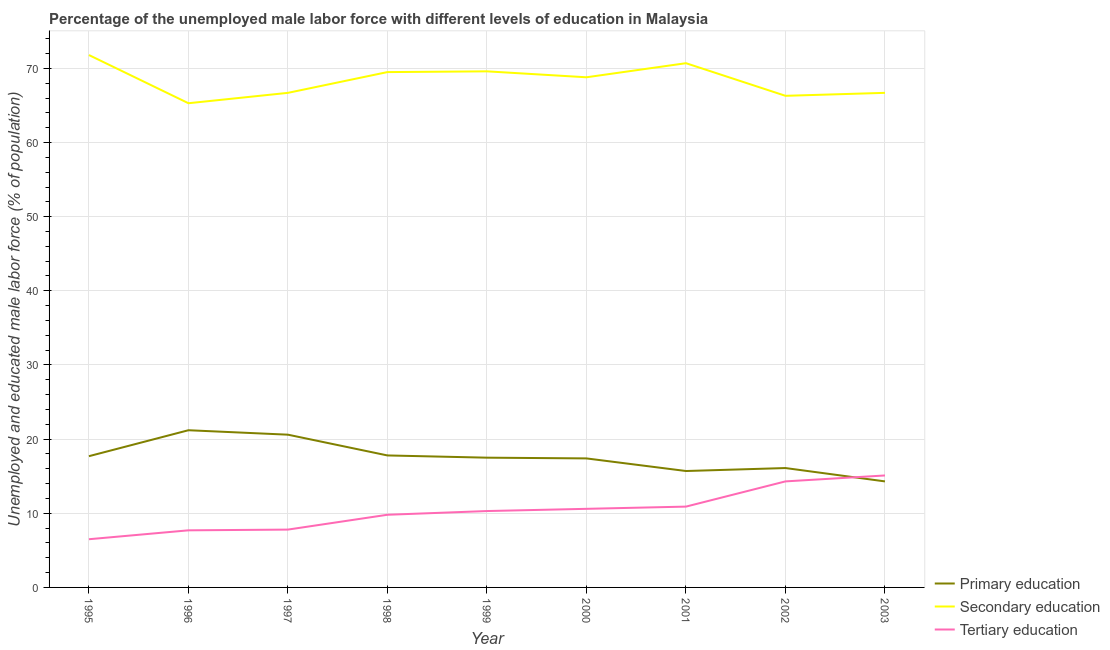What is the percentage of male labor force who received primary education in 1998?
Ensure brevity in your answer.  17.8. Across all years, what is the maximum percentage of male labor force who received tertiary education?
Ensure brevity in your answer.  15.1. Across all years, what is the minimum percentage of male labor force who received secondary education?
Offer a very short reply. 65.3. In which year was the percentage of male labor force who received primary education minimum?
Offer a terse response. 2003. What is the total percentage of male labor force who received primary education in the graph?
Keep it short and to the point. 158.3. What is the difference between the percentage of male labor force who received tertiary education in 1996 and that in 1999?
Ensure brevity in your answer.  -2.6. What is the difference between the percentage of male labor force who received tertiary education in 1995 and the percentage of male labor force who received primary education in 2003?
Your answer should be very brief. -7.8. What is the average percentage of male labor force who received primary education per year?
Keep it short and to the point. 17.59. In the year 1998, what is the difference between the percentage of male labor force who received tertiary education and percentage of male labor force who received secondary education?
Your response must be concise. -59.7. In how many years, is the percentage of male labor force who received tertiary education greater than 44 %?
Make the answer very short. 0. What is the ratio of the percentage of male labor force who received secondary education in 1996 to that in 2003?
Ensure brevity in your answer.  0.98. What is the difference between the highest and the second highest percentage of male labor force who received primary education?
Ensure brevity in your answer.  0.6. Is the sum of the percentage of male labor force who received tertiary education in 1999 and 2000 greater than the maximum percentage of male labor force who received primary education across all years?
Offer a terse response. No. Does the percentage of male labor force who received primary education monotonically increase over the years?
Ensure brevity in your answer.  No. Is the percentage of male labor force who received tertiary education strictly greater than the percentage of male labor force who received secondary education over the years?
Offer a very short reply. No. Is the percentage of male labor force who received tertiary education strictly less than the percentage of male labor force who received secondary education over the years?
Provide a short and direct response. Yes. How many years are there in the graph?
Your answer should be very brief. 9. What is the difference between two consecutive major ticks on the Y-axis?
Provide a succinct answer. 10. Does the graph contain any zero values?
Keep it short and to the point. No. How many legend labels are there?
Provide a short and direct response. 3. What is the title of the graph?
Offer a very short reply. Percentage of the unemployed male labor force with different levels of education in Malaysia. Does "Interest" appear as one of the legend labels in the graph?
Offer a very short reply. No. What is the label or title of the X-axis?
Offer a very short reply. Year. What is the label or title of the Y-axis?
Provide a succinct answer. Unemployed and educated male labor force (% of population). What is the Unemployed and educated male labor force (% of population) in Primary education in 1995?
Your answer should be very brief. 17.7. What is the Unemployed and educated male labor force (% of population) of Secondary education in 1995?
Offer a very short reply. 71.8. What is the Unemployed and educated male labor force (% of population) of Tertiary education in 1995?
Provide a short and direct response. 6.5. What is the Unemployed and educated male labor force (% of population) of Primary education in 1996?
Your response must be concise. 21.2. What is the Unemployed and educated male labor force (% of population) in Secondary education in 1996?
Ensure brevity in your answer.  65.3. What is the Unemployed and educated male labor force (% of population) of Tertiary education in 1996?
Your answer should be compact. 7.7. What is the Unemployed and educated male labor force (% of population) of Primary education in 1997?
Your answer should be compact. 20.6. What is the Unemployed and educated male labor force (% of population) of Secondary education in 1997?
Give a very brief answer. 66.7. What is the Unemployed and educated male labor force (% of population) in Tertiary education in 1997?
Make the answer very short. 7.8. What is the Unemployed and educated male labor force (% of population) in Primary education in 1998?
Offer a terse response. 17.8. What is the Unemployed and educated male labor force (% of population) in Secondary education in 1998?
Make the answer very short. 69.5. What is the Unemployed and educated male labor force (% of population) in Tertiary education in 1998?
Provide a succinct answer. 9.8. What is the Unemployed and educated male labor force (% of population) of Secondary education in 1999?
Provide a succinct answer. 69.6. What is the Unemployed and educated male labor force (% of population) of Tertiary education in 1999?
Provide a succinct answer. 10.3. What is the Unemployed and educated male labor force (% of population) in Primary education in 2000?
Your response must be concise. 17.4. What is the Unemployed and educated male labor force (% of population) in Secondary education in 2000?
Your answer should be very brief. 68.8. What is the Unemployed and educated male labor force (% of population) of Tertiary education in 2000?
Provide a short and direct response. 10.6. What is the Unemployed and educated male labor force (% of population) in Primary education in 2001?
Your answer should be very brief. 15.7. What is the Unemployed and educated male labor force (% of population) of Secondary education in 2001?
Ensure brevity in your answer.  70.7. What is the Unemployed and educated male labor force (% of population) of Tertiary education in 2001?
Ensure brevity in your answer.  10.9. What is the Unemployed and educated male labor force (% of population) in Primary education in 2002?
Ensure brevity in your answer.  16.1. What is the Unemployed and educated male labor force (% of population) in Secondary education in 2002?
Offer a very short reply. 66.3. What is the Unemployed and educated male labor force (% of population) in Tertiary education in 2002?
Offer a very short reply. 14.3. What is the Unemployed and educated male labor force (% of population) of Primary education in 2003?
Offer a terse response. 14.3. What is the Unemployed and educated male labor force (% of population) in Secondary education in 2003?
Ensure brevity in your answer.  66.7. What is the Unemployed and educated male labor force (% of population) in Tertiary education in 2003?
Ensure brevity in your answer.  15.1. Across all years, what is the maximum Unemployed and educated male labor force (% of population) in Primary education?
Offer a terse response. 21.2. Across all years, what is the maximum Unemployed and educated male labor force (% of population) in Secondary education?
Provide a succinct answer. 71.8. Across all years, what is the maximum Unemployed and educated male labor force (% of population) in Tertiary education?
Your response must be concise. 15.1. Across all years, what is the minimum Unemployed and educated male labor force (% of population) in Primary education?
Provide a short and direct response. 14.3. Across all years, what is the minimum Unemployed and educated male labor force (% of population) of Secondary education?
Your response must be concise. 65.3. What is the total Unemployed and educated male labor force (% of population) in Primary education in the graph?
Provide a succinct answer. 158.3. What is the total Unemployed and educated male labor force (% of population) in Secondary education in the graph?
Ensure brevity in your answer.  615.4. What is the total Unemployed and educated male labor force (% of population) of Tertiary education in the graph?
Your answer should be very brief. 93. What is the difference between the Unemployed and educated male labor force (% of population) of Primary education in 1995 and that in 1996?
Your answer should be very brief. -3.5. What is the difference between the Unemployed and educated male labor force (% of population) of Secondary education in 1995 and that in 1996?
Provide a succinct answer. 6.5. What is the difference between the Unemployed and educated male labor force (% of population) of Tertiary education in 1995 and that in 1996?
Make the answer very short. -1.2. What is the difference between the Unemployed and educated male labor force (% of population) of Secondary education in 1995 and that in 1997?
Ensure brevity in your answer.  5.1. What is the difference between the Unemployed and educated male labor force (% of population) in Primary education in 1995 and that in 1998?
Offer a terse response. -0.1. What is the difference between the Unemployed and educated male labor force (% of population) in Primary education in 1995 and that in 2000?
Offer a terse response. 0.3. What is the difference between the Unemployed and educated male labor force (% of population) in Tertiary education in 1995 and that in 2000?
Your answer should be very brief. -4.1. What is the difference between the Unemployed and educated male labor force (% of population) of Primary education in 1995 and that in 2001?
Ensure brevity in your answer.  2. What is the difference between the Unemployed and educated male labor force (% of population) of Secondary education in 1995 and that in 2001?
Make the answer very short. 1.1. What is the difference between the Unemployed and educated male labor force (% of population) of Primary education in 1995 and that in 2002?
Offer a very short reply. 1.6. What is the difference between the Unemployed and educated male labor force (% of population) of Tertiary education in 1995 and that in 2003?
Your answer should be very brief. -8.6. What is the difference between the Unemployed and educated male labor force (% of population) in Primary education in 1996 and that in 1998?
Keep it short and to the point. 3.4. What is the difference between the Unemployed and educated male labor force (% of population) of Secondary education in 1996 and that in 1998?
Ensure brevity in your answer.  -4.2. What is the difference between the Unemployed and educated male labor force (% of population) of Primary education in 1996 and that in 1999?
Offer a terse response. 3.7. What is the difference between the Unemployed and educated male labor force (% of population) in Primary education in 1996 and that in 2000?
Ensure brevity in your answer.  3.8. What is the difference between the Unemployed and educated male labor force (% of population) in Primary education in 1996 and that in 2002?
Offer a terse response. 5.1. What is the difference between the Unemployed and educated male labor force (% of population) of Primary education in 1996 and that in 2003?
Make the answer very short. 6.9. What is the difference between the Unemployed and educated male labor force (% of population) of Secondary education in 1996 and that in 2003?
Make the answer very short. -1.4. What is the difference between the Unemployed and educated male labor force (% of population) of Tertiary education in 1996 and that in 2003?
Give a very brief answer. -7.4. What is the difference between the Unemployed and educated male labor force (% of population) in Primary education in 1997 and that in 1998?
Keep it short and to the point. 2.8. What is the difference between the Unemployed and educated male labor force (% of population) of Primary education in 1997 and that in 1999?
Offer a terse response. 3.1. What is the difference between the Unemployed and educated male labor force (% of population) of Tertiary education in 1997 and that in 1999?
Give a very brief answer. -2.5. What is the difference between the Unemployed and educated male labor force (% of population) of Primary education in 1997 and that in 2000?
Make the answer very short. 3.2. What is the difference between the Unemployed and educated male labor force (% of population) of Secondary education in 1997 and that in 2000?
Make the answer very short. -2.1. What is the difference between the Unemployed and educated male labor force (% of population) of Secondary education in 1997 and that in 2001?
Make the answer very short. -4. What is the difference between the Unemployed and educated male labor force (% of population) in Primary education in 1997 and that in 2002?
Offer a terse response. 4.5. What is the difference between the Unemployed and educated male labor force (% of population) in Secondary education in 1997 and that in 2002?
Your answer should be very brief. 0.4. What is the difference between the Unemployed and educated male labor force (% of population) of Primary education in 1997 and that in 2003?
Offer a very short reply. 6.3. What is the difference between the Unemployed and educated male labor force (% of population) in Primary education in 1998 and that in 2000?
Provide a succinct answer. 0.4. What is the difference between the Unemployed and educated male labor force (% of population) of Secondary education in 1998 and that in 2000?
Give a very brief answer. 0.7. What is the difference between the Unemployed and educated male labor force (% of population) of Primary education in 1998 and that in 2001?
Offer a very short reply. 2.1. What is the difference between the Unemployed and educated male labor force (% of population) of Secondary education in 1998 and that in 2001?
Make the answer very short. -1.2. What is the difference between the Unemployed and educated male labor force (% of population) in Primary education in 1998 and that in 2003?
Provide a succinct answer. 3.5. What is the difference between the Unemployed and educated male labor force (% of population) of Primary education in 1999 and that in 2000?
Your answer should be very brief. 0.1. What is the difference between the Unemployed and educated male labor force (% of population) of Primary education in 1999 and that in 2001?
Provide a succinct answer. 1.8. What is the difference between the Unemployed and educated male labor force (% of population) in Secondary education in 1999 and that in 2002?
Provide a succinct answer. 3.3. What is the difference between the Unemployed and educated male labor force (% of population) in Secondary education in 1999 and that in 2003?
Give a very brief answer. 2.9. What is the difference between the Unemployed and educated male labor force (% of population) of Primary education in 2000 and that in 2001?
Give a very brief answer. 1.7. What is the difference between the Unemployed and educated male labor force (% of population) of Secondary education in 2000 and that in 2002?
Give a very brief answer. 2.5. What is the difference between the Unemployed and educated male labor force (% of population) of Tertiary education in 2000 and that in 2002?
Your answer should be very brief. -3.7. What is the difference between the Unemployed and educated male labor force (% of population) of Primary education in 2000 and that in 2003?
Your answer should be compact. 3.1. What is the difference between the Unemployed and educated male labor force (% of population) of Secondary education in 2000 and that in 2003?
Your answer should be very brief. 2.1. What is the difference between the Unemployed and educated male labor force (% of population) in Tertiary education in 2000 and that in 2003?
Make the answer very short. -4.5. What is the difference between the Unemployed and educated male labor force (% of population) in Primary education in 2001 and that in 2002?
Your answer should be compact. -0.4. What is the difference between the Unemployed and educated male labor force (% of population) in Primary education in 2001 and that in 2003?
Ensure brevity in your answer.  1.4. What is the difference between the Unemployed and educated male labor force (% of population) of Secondary education in 2001 and that in 2003?
Provide a short and direct response. 4. What is the difference between the Unemployed and educated male labor force (% of population) of Tertiary education in 2001 and that in 2003?
Provide a succinct answer. -4.2. What is the difference between the Unemployed and educated male labor force (% of population) of Primary education in 2002 and that in 2003?
Offer a terse response. 1.8. What is the difference between the Unemployed and educated male labor force (% of population) in Secondary education in 2002 and that in 2003?
Provide a succinct answer. -0.4. What is the difference between the Unemployed and educated male labor force (% of population) of Primary education in 1995 and the Unemployed and educated male labor force (% of population) of Secondary education in 1996?
Your answer should be very brief. -47.6. What is the difference between the Unemployed and educated male labor force (% of population) in Secondary education in 1995 and the Unemployed and educated male labor force (% of population) in Tertiary education in 1996?
Ensure brevity in your answer.  64.1. What is the difference between the Unemployed and educated male labor force (% of population) of Primary education in 1995 and the Unemployed and educated male labor force (% of population) of Secondary education in 1997?
Offer a terse response. -49. What is the difference between the Unemployed and educated male labor force (% of population) in Primary education in 1995 and the Unemployed and educated male labor force (% of population) in Tertiary education in 1997?
Provide a succinct answer. 9.9. What is the difference between the Unemployed and educated male labor force (% of population) of Primary education in 1995 and the Unemployed and educated male labor force (% of population) of Secondary education in 1998?
Offer a very short reply. -51.8. What is the difference between the Unemployed and educated male labor force (% of population) in Primary education in 1995 and the Unemployed and educated male labor force (% of population) in Secondary education in 1999?
Make the answer very short. -51.9. What is the difference between the Unemployed and educated male labor force (% of population) of Primary education in 1995 and the Unemployed and educated male labor force (% of population) of Tertiary education in 1999?
Offer a very short reply. 7.4. What is the difference between the Unemployed and educated male labor force (% of population) in Secondary education in 1995 and the Unemployed and educated male labor force (% of population) in Tertiary education in 1999?
Your answer should be very brief. 61.5. What is the difference between the Unemployed and educated male labor force (% of population) in Primary education in 1995 and the Unemployed and educated male labor force (% of population) in Secondary education in 2000?
Make the answer very short. -51.1. What is the difference between the Unemployed and educated male labor force (% of population) of Primary education in 1995 and the Unemployed and educated male labor force (% of population) of Tertiary education in 2000?
Give a very brief answer. 7.1. What is the difference between the Unemployed and educated male labor force (% of population) in Secondary education in 1995 and the Unemployed and educated male labor force (% of population) in Tertiary education in 2000?
Your response must be concise. 61.2. What is the difference between the Unemployed and educated male labor force (% of population) of Primary education in 1995 and the Unemployed and educated male labor force (% of population) of Secondary education in 2001?
Your answer should be compact. -53. What is the difference between the Unemployed and educated male labor force (% of population) of Primary education in 1995 and the Unemployed and educated male labor force (% of population) of Tertiary education in 2001?
Offer a terse response. 6.8. What is the difference between the Unemployed and educated male labor force (% of population) in Secondary education in 1995 and the Unemployed and educated male labor force (% of population) in Tertiary education in 2001?
Your answer should be compact. 60.9. What is the difference between the Unemployed and educated male labor force (% of population) in Primary education in 1995 and the Unemployed and educated male labor force (% of population) in Secondary education in 2002?
Offer a very short reply. -48.6. What is the difference between the Unemployed and educated male labor force (% of population) in Secondary education in 1995 and the Unemployed and educated male labor force (% of population) in Tertiary education in 2002?
Make the answer very short. 57.5. What is the difference between the Unemployed and educated male labor force (% of population) in Primary education in 1995 and the Unemployed and educated male labor force (% of population) in Secondary education in 2003?
Keep it short and to the point. -49. What is the difference between the Unemployed and educated male labor force (% of population) in Secondary education in 1995 and the Unemployed and educated male labor force (% of population) in Tertiary education in 2003?
Provide a short and direct response. 56.7. What is the difference between the Unemployed and educated male labor force (% of population) of Primary education in 1996 and the Unemployed and educated male labor force (% of population) of Secondary education in 1997?
Your answer should be compact. -45.5. What is the difference between the Unemployed and educated male labor force (% of population) of Secondary education in 1996 and the Unemployed and educated male labor force (% of population) of Tertiary education in 1997?
Your answer should be compact. 57.5. What is the difference between the Unemployed and educated male labor force (% of population) of Primary education in 1996 and the Unemployed and educated male labor force (% of population) of Secondary education in 1998?
Provide a short and direct response. -48.3. What is the difference between the Unemployed and educated male labor force (% of population) in Secondary education in 1996 and the Unemployed and educated male labor force (% of population) in Tertiary education in 1998?
Keep it short and to the point. 55.5. What is the difference between the Unemployed and educated male labor force (% of population) of Primary education in 1996 and the Unemployed and educated male labor force (% of population) of Secondary education in 1999?
Provide a succinct answer. -48.4. What is the difference between the Unemployed and educated male labor force (% of population) of Secondary education in 1996 and the Unemployed and educated male labor force (% of population) of Tertiary education in 1999?
Offer a terse response. 55. What is the difference between the Unemployed and educated male labor force (% of population) of Primary education in 1996 and the Unemployed and educated male labor force (% of population) of Secondary education in 2000?
Provide a succinct answer. -47.6. What is the difference between the Unemployed and educated male labor force (% of population) in Primary education in 1996 and the Unemployed and educated male labor force (% of population) in Tertiary education in 2000?
Give a very brief answer. 10.6. What is the difference between the Unemployed and educated male labor force (% of population) of Secondary education in 1996 and the Unemployed and educated male labor force (% of population) of Tertiary education in 2000?
Offer a very short reply. 54.7. What is the difference between the Unemployed and educated male labor force (% of population) in Primary education in 1996 and the Unemployed and educated male labor force (% of population) in Secondary education in 2001?
Give a very brief answer. -49.5. What is the difference between the Unemployed and educated male labor force (% of population) in Secondary education in 1996 and the Unemployed and educated male labor force (% of population) in Tertiary education in 2001?
Your answer should be compact. 54.4. What is the difference between the Unemployed and educated male labor force (% of population) of Primary education in 1996 and the Unemployed and educated male labor force (% of population) of Secondary education in 2002?
Offer a very short reply. -45.1. What is the difference between the Unemployed and educated male labor force (% of population) of Primary education in 1996 and the Unemployed and educated male labor force (% of population) of Tertiary education in 2002?
Provide a succinct answer. 6.9. What is the difference between the Unemployed and educated male labor force (% of population) of Primary education in 1996 and the Unemployed and educated male labor force (% of population) of Secondary education in 2003?
Provide a short and direct response. -45.5. What is the difference between the Unemployed and educated male labor force (% of population) in Secondary education in 1996 and the Unemployed and educated male labor force (% of population) in Tertiary education in 2003?
Offer a terse response. 50.2. What is the difference between the Unemployed and educated male labor force (% of population) in Primary education in 1997 and the Unemployed and educated male labor force (% of population) in Secondary education in 1998?
Ensure brevity in your answer.  -48.9. What is the difference between the Unemployed and educated male labor force (% of population) in Secondary education in 1997 and the Unemployed and educated male labor force (% of population) in Tertiary education in 1998?
Keep it short and to the point. 56.9. What is the difference between the Unemployed and educated male labor force (% of population) in Primary education in 1997 and the Unemployed and educated male labor force (% of population) in Secondary education in 1999?
Ensure brevity in your answer.  -49. What is the difference between the Unemployed and educated male labor force (% of population) of Secondary education in 1997 and the Unemployed and educated male labor force (% of population) of Tertiary education in 1999?
Provide a succinct answer. 56.4. What is the difference between the Unemployed and educated male labor force (% of population) of Primary education in 1997 and the Unemployed and educated male labor force (% of population) of Secondary education in 2000?
Offer a very short reply. -48.2. What is the difference between the Unemployed and educated male labor force (% of population) in Primary education in 1997 and the Unemployed and educated male labor force (% of population) in Tertiary education in 2000?
Keep it short and to the point. 10. What is the difference between the Unemployed and educated male labor force (% of population) of Secondary education in 1997 and the Unemployed and educated male labor force (% of population) of Tertiary education in 2000?
Give a very brief answer. 56.1. What is the difference between the Unemployed and educated male labor force (% of population) of Primary education in 1997 and the Unemployed and educated male labor force (% of population) of Secondary education in 2001?
Your response must be concise. -50.1. What is the difference between the Unemployed and educated male labor force (% of population) in Secondary education in 1997 and the Unemployed and educated male labor force (% of population) in Tertiary education in 2001?
Provide a succinct answer. 55.8. What is the difference between the Unemployed and educated male labor force (% of population) of Primary education in 1997 and the Unemployed and educated male labor force (% of population) of Secondary education in 2002?
Give a very brief answer. -45.7. What is the difference between the Unemployed and educated male labor force (% of population) of Primary education in 1997 and the Unemployed and educated male labor force (% of population) of Tertiary education in 2002?
Offer a terse response. 6.3. What is the difference between the Unemployed and educated male labor force (% of population) in Secondary education in 1997 and the Unemployed and educated male labor force (% of population) in Tertiary education in 2002?
Offer a very short reply. 52.4. What is the difference between the Unemployed and educated male labor force (% of population) in Primary education in 1997 and the Unemployed and educated male labor force (% of population) in Secondary education in 2003?
Provide a short and direct response. -46.1. What is the difference between the Unemployed and educated male labor force (% of population) in Primary education in 1997 and the Unemployed and educated male labor force (% of population) in Tertiary education in 2003?
Ensure brevity in your answer.  5.5. What is the difference between the Unemployed and educated male labor force (% of population) of Secondary education in 1997 and the Unemployed and educated male labor force (% of population) of Tertiary education in 2003?
Your answer should be compact. 51.6. What is the difference between the Unemployed and educated male labor force (% of population) of Primary education in 1998 and the Unemployed and educated male labor force (% of population) of Secondary education in 1999?
Ensure brevity in your answer.  -51.8. What is the difference between the Unemployed and educated male labor force (% of population) of Primary education in 1998 and the Unemployed and educated male labor force (% of population) of Tertiary education in 1999?
Ensure brevity in your answer.  7.5. What is the difference between the Unemployed and educated male labor force (% of population) of Secondary education in 1998 and the Unemployed and educated male labor force (% of population) of Tertiary education in 1999?
Your answer should be compact. 59.2. What is the difference between the Unemployed and educated male labor force (% of population) of Primary education in 1998 and the Unemployed and educated male labor force (% of population) of Secondary education in 2000?
Provide a succinct answer. -51. What is the difference between the Unemployed and educated male labor force (% of population) of Primary education in 1998 and the Unemployed and educated male labor force (% of population) of Tertiary education in 2000?
Provide a succinct answer. 7.2. What is the difference between the Unemployed and educated male labor force (% of population) of Secondary education in 1998 and the Unemployed and educated male labor force (% of population) of Tertiary education in 2000?
Your response must be concise. 58.9. What is the difference between the Unemployed and educated male labor force (% of population) of Primary education in 1998 and the Unemployed and educated male labor force (% of population) of Secondary education in 2001?
Make the answer very short. -52.9. What is the difference between the Unemployed and educated male labor force (% of population) of Secondary education in 1998 and the Unemployed and educated male labor force (% of population) of Tertiary education in 2001?
Keep it short and to the point. 58.6. What is the difference between the Unemployed and educated male labor force (% of population) in Primary education in 1998 and the Unemployed and educated male labor force (% of population) in Secondary education in 2002?
Offer a very short reply. -48.5. What is the difference between the Unemployed and educated male labor force (% of population) of Primary education in 1998 and the Unemployed and educated male labor force (% of population) of Tertiary education in 2002?
Your answer should be very brief. 3.5. What is the difference between the Unemployed and educated male labor force (% of population) in Secondary education in 1998 and the Unemployed and educated male labor force (% of population) in Tertiary education in 2002?
Keep it short and to the point. 55.2. What is the difference between the Unemployed and educated male labor force (% of population) in Primary education in 1998 and the Unemployed and educated male labor force (% of population) in Secondary education in 2003?
Make the answer very short. -48.9. What is the difference between the Unemployed and educated male labor force (% of population) of Primary education in 1998 and the Unemployed and educated male labor force (% of population) of Tertiary education in 2003?
Make the answer very short. 2.7. What is the difference between the Unemployed and educated male labor force (% of population) of Secondary education in 1998 and the Unemployed and educated male labor force (% of population) of Tertiary education in 2003?
Give a very brief answer. 54.4. What is the difference between the Unemployed and educated male labor force (% of population) of Primary education in 1999 and the Unemployed and educated male labor force (% of population) of Secondary education in 2000?
Your answer should be compact. -51.3. What is the difference between the Unemployed and educated male labor force (% of population) of Primary education in 1999 and the Unemployed and educated male labor force (% of population) of Secondary education in 2001?
Provide a succinct answer. -53.2. What is the difference between the Unemployed and educated male labor force (% of population) in Secondary education in 1999 and the Unemployed and educated male labor force (% of population) in Tertiary education in 2001?
Your answer should be very brief. 58.7. What is the difference between the Unemployed and educated male labor force (% of population) of Primary education in 1999 and the Unemployed and educated male labor force (% of population) of Secondary education in 2002?
Make the answer very short. -48.8. What is the difference between the Unemployed and educated male labor force (% of population) of Secondary education in 1999 and the Unemployed and educated male labor force (% of population) of Tertiary education in 2002?
Provide a succinct answer. 55.3. What is the difference between the Unemployed and educated male labor force (% of population) of Primary education in 1999 and the Unemployed and educated male labor force (% of population) of Secondary education in 2003?
Your answer should be very brief. -49.2. What is the difference between the Unemployed and educated male labor force (% of population) of Primary education in 1999 and the Unemployed and educated male labor force (% of population) of Tertiary education in 2003?
Offer a terse response. 2.4. What is the difference between the Unemployed and educated male labor force (% of population) in Secondary education in 1999 and the Unemployed and educated male labor force (% of population) in Tertiary education in 2003?
Offer a very short reply. 54.5. What is the difference between the Unemployed and educated male labor force (% of population) of Primary education in 2000 and the Unemployed and educated male labor force (% of population) of Secondary education in 2001?
Ensure brevity in your answer.  -53.3. What is the difference between the Unemployed and educated male labor force (% of population) in Primary education in 2000 and the Unemployed and educated male labor force (% of population) in Tertiary education in 2001?
Your response must be concise. 6.5. What is the difference between the Unemployed and educated male labor force (% of population) in Secondary education in 2000 and the Unemployed and educated male labor force (% of population) in Tertiary education in 2001?
Provide a short and direct response. 57.9. What is the difference between the Unemployed and educated male labor force (% of population) of Primary education in 2000 and the Unemployed and educated male labor force (% of population) of Secondary education in 2002?
Keep it short and to the point. -48.9. What is the difference between the Unemployed and educated male labor force (% of population) of Secondary education in 2000 and the Unemployed and educated male labor force (% of population) of Tertiary education in 2002?
Make the answer very short. 54.5. What is the difference between the Unemployed and educated male labor force (% of population) in Primary education in 2000 and the Unemployed and educated male labor force (% of population) in Secondary education in 2003?
Offer a terse response. -49.3. What is the difference between the Unemployed and educated male labor force (% of population) of Secondary education in 2000 and the Unemployed and educated male labor force (% of population) of Tertiary education in 2003?
Offer a terse response. 53.7. What is the difference between the Unemployed and educated male labor force (% of population) in Primary education in 2001 and the Unemployed and educated male labor force (% of population) in Secondary education in 2002?
Offer a terse response. -50.6. What is the difference between the Unemployed and educated male labor force (% of population) of Secondary education in 2001 and the Unemployed and educated male labor force (% of population) of Tertiary education in 2002?
Give a very brief answer. 56.4. What is the difference between the Unemployed and educated male labor force (% of population) in Primary education in 2001 and the Unemployed and educated male labor force (% of population) in Secondary education in 2003?
Your answer should be compact. -51. What is the difference between the Unemployed and educated male labor force (% of population) of Primary education in 2001 and the Unemployed and educated male labor force (% of population) of Tertiary education in 2003?
Make the answer very short. 0.6. What is the difference between the Unemployed and educated male labor force (% of population) in Secondary education in 2001 and the Unemployed and educated male labor force (% of population) in Tertiary education in 2003?
Provide a succinct answer. 55.6. What is the difference between the Unemployed and educated male labor force (% of population) in Primary education in 2002 and the Unemployed and educated male labor force (% of population) in Secondary education in 2003?
Offer a very short reply. -50.6. What is the difference between the Unemployed and educated male labor force (% of population) in Primary education in 2002 and the Unemployed and educated male labor force (% of population) in Tertiary education in 2003?
Ensure brevity in your answer.  1. What is the difference between the Unemployed and educated male labor force (% of population) in Secondary education in 2002 and the Unemployed and educated male labor force (% of population) in Tertiary education in 2003?
Provide a succinct answer. 51.2. What is the average Unemployed and educated male labor force (% of population) of Primary education per year?
Keep it short and to the point. 17.59. What is the average Unemployed and educated male labor force (% of population) in Secondary education per year?
Your answer should be compact. 68.38. What is the average Unemployed and educated male labor force (% of population) of Tertiary education per year?
Your answer should be very brief. 10.33. In the year 1995, what is the difference between the Unemployed and educated male labor force (% of population) of Primary education and Unemployed and educated male labor force (% of population) of Secondary education?
Make the answer very short. -54.1. In the year 1995, what is the difference between the Unemployed and educated male labor force (% of population) in Secondary education and Unemployed and educated male labor force (% of population) in Tertiary education?
Provide a short and direct response. 65.3. In the year 1996, what is the difference between the Unemployed and educated male labor force (% of population) in Primary education and Unemployed and educated male labor force (% of population) in Secondary education?
Your response must be concise. -44.1. In the year 1996, what is the difference between the Unemployed and educated male labor force (% of population) in Primary education and Unemployed and educated male labor force (% of population) in Tertiary education?
Provide a succinct answer. 13.5. In the year 1996, what is the difference between the Unemployed and educated male labor force (% of population) of Secondary education and Unemployed and educated male labor force (% of population) of Tertiary education?
Your answer should be very brief. 57.6. In the year 1997, what is the difference between the Unemployed and educated male labor force (% of population) of Primary education and Unemployed and educated male labor force (% of population) of Secondary education?
Your answer should be very brief. -46.1. In the year 1997, what is the difference between the Unemployed and educated male labor force (% of population) of Primary education and Unemployed and educated male labor force (% of population) of Tertiary education?
Provide a short and direct response. 12.8. In the year 1997, what is the difference between the Unemployed and educated male labor force (% of population) of Secondary education and Unemployed and educated male labor force (% of population) of Tertiary education?
Your response must be concise. 58.9. In the year 1998, what is the difference between the Unemployed and educated male labor force (% of population) in Primary education and Unemployed and educated male labor force (% of population) in Secondary education?
Offer a terse response. -51.7. In the year 1998, what is the difference between the Unemployed and educated male labor force (% of population) of Primary education and Unemployed and educated male labor force (% of population) of Tertiary education?
Your answer should be very brief. 8. In the year 1998, what is the difference between the Unemployed and educated male labor force (% of population) in Secondary education and Unemployed and educated male labor force (% of population) in Tertiary education?
Your response must be concise. 59.7. In the year 1999, what is the difference between the Unemployed and educated male labor force (% of population) in Primary education and Unemployed and educated male labor force (% of population) in Secondary education?
Offer a very short reply. -52.1. In the year 1999, what is the difference between the Unemployed and educated male labor force (% of population) in Secondary education and Unemployed and educated male labor force (% of population) in Tertiary education?
Keep it short and to the point. 59.3. In the year 2000, what is the difference between the Unemployed and educated male labor force (% of population) in Primary education and Unemployed and educated male labor force (% of population) in Secondary education?
Offer a terse response. -51.4. In the year 2000, what is the difference between the Unemployed and educated male labor force (% of population) in Secondary education and Unemployed and educated male labor force (% of population) in Tertiary education?
Ensure brevity in your answer.  58.2. In the year 2001, what is the difference between the Unemployed and educated male labor force (% of population) of Primary education and Unemployed and educated male labor force (% of population) of Secondary education?
Offer a very short reply. -55. In the year 2001, what is the difference between the Unemployed and educated male labor force (% of population) of Primary education and Unemployed and educated male labor force (% of population) of Tertiary education?
Make the answer very short. 4.8. In the year 2001, what is the difference between the Unemployed and educated male labor force (% of population) of Secondary education and Unemployed and educated male labor force (% of population) of Tertiary education?
Make the answer very short. 59.8. In the year 2002, what is the difference between the Unemployed and educated male labor force (% of population) in Primary education and Unemployed and educated male labor force (% of population) in Secondary education?
Offer a very short reply. -50.2. In the year 2002, what is the difference between the Unemployed and educated male labor force (% of population) in Secondary education and Unemployed and educated male labor force (% of population) in Tertiary education?
Ensure brevity in your answer.  52. In the year 2003, what is the difference between the Unemployed and educated male labor force (% of population) in Primary education and Unemployed and educated male labor force (% of population) in Secondary education?
Provide a succinct answer. -52.4. In the year 2003, what is the difference between the Unemployed and educated male labor force (% of population) in Primary education and Unemployed and educated male labor force (% of population) in Tertiary education?
Give a very brief answer. -0.8. In the year 2003, what is the difference between the Unemployed and educated male labor force (% of population) in Secondary education and Unemployed and educated male labor force (% of population) in Tertiary education?
Your response must be concise. 51.6. What is the ratio of the Unemployed and educated male labor force (% of population) of Primary education in 1995 to that in 1996?
Offer a terse response. 0.83. What is the ratio of the Unemployed and educated male labor force (% of population) in Secondary education in 1995 to that in 1996?
Provide a short and direct response. 1.1. What is the ratio of the Unemployed and educated male labor force (% of population) in Tertiary education in 1995 to that in 1996?
Provide a succinct answer. 0.84. What is the ratio of the Unemployed and educated male labor force (% of population) in Primary education in 1995 to that in 1997?
Ensure brevity in your answer.  0.86. What is the ratio of the Unemployed and educated male labor force (% of population) in Secondary education in 1995 to that in 1997?
Give a very brief answer. 1.08. What is the ratio of the Unemployed and educated male labor force (% of population) of Primary education in 1995 to that in 1998?
Give a very brief answer. 0.99. What is the ratio of the Unemployed and educated male labor force (% of population) of Secondary education in 1995 to that in 1998?
Keep it short and to the point. 1.03. What is the ratio of the Unemployed and educated male labor force (% of population) of Tertiary education in 1995 to that in 1998?
Your answer should be compact. 0.66. What is the ratio of the Unemployed and educated male labor force (% of population) of Primary education in 1995 to that in 1999?
Make the answer very short. 1.01. What is the ratio of the Unemployed and educated male labor force (% of population) in Secondary education in 1995 to that in 1999?
Your response must be concise. 1.03. What is the ratio of the Unemployed and educated male labor force (% of population) in Tertiary education in 1995 to that in 1999?
Your response must be concise. 0.63. What is the ratio of the Unemployed and educated male labor force (% of population) in Primary education in 1995 to that in 2000?
Offer a very short reply. 1.02. What is the ratio of the Unemployed and educated male labor force (% of population) in Secondary education in 1995 to that in 2000?
Ensure brevity in your answer.  1.04. What is the ratio of the Unemployed and educated male labor force (% of population) in Tertiary education in 1995 to that in 2000?
Ensure brevity in your answer.  0.61. What is the ratio of the Unemployed and educated male labor force (% of population) in Primary education in 1995 to that in 2001?
Offer a terse response. 1.13. What is the ratio of the Unemployed and educated male labor force (% of population) in Secondary education in 1995 to that in 2001?
Provide a short and direct response. 1.02. What is the ratio of the Unemployed and educated male labor force (% of population) in Tertiary education in 1995 to that in 2001?
Your answer should be very brief. 0.6. What is the ratio of the Unemployed and educated male labor force (% of population) in Primary education in 1995 to that in 2002?
Provide a short and direct response. 1.1. What is the ratio of the Unemployed and educated male labor force (% of population) in Secondary education in 1995 to that in 2002?
Offer a very short reply. 1.08. What is the ratio of the Unemployed and educated male labor force (% of population) in Tertiary education in 1995 to that in 2002?
Provide a short and direct response. 0.45. What is the ratio of the Unemployed and educated male labor force (% of population) in Primary education in 1995 to that in 2003?
Offer a very short reply. 1.24. What is the ratio of the Unemployed and educated male labor force (% of population) of Secondary education in 1995 to that in 2003?
Your answer should be very brief. 1.08. What is the ratio of the Unemployed and educated male labor force (% of population) of Tertiary education in 1995 to that in 2003?
Give a very brief answer. 0.43. What is the ratio of the Unemployed and educated male labor force (% of population) of Primary education in 1996 to that in 1997?
Provide a succinct answer. 1.03. What is the ratio of the Unemployed and educated male labor force (% of population) in Secondary education in 1996 to that in 1997?
Your answer should be very brief. 0.98. What is the ratio of the Unemployed and educated male labor force (% of population) of Tertiary education in 1996 to that in 1997?
Your answer should be very brief. 0.99. What is the ratio of the Unemployed and educated male labor force (% of population) of Primary education in 1996 to that in 1998?
Offer a terse response. 1.19. What is the ratio of the Unemployed and educated male labor force (% of population) in Secondary education in 1996 to that in 1998?
Provide a short and direct response. 0.94. What is the ratio of the Unemployed and educated male labor force (% of population) of Tertiary education in 1996 to that in 1998?
Offer a very short reply. 0.79. What is the ratio of the Unemployed and educated male labor force (% of population) in Primary education in 1996 to that in 1999?
Offer a terse response. 1.21. What is the ratio of the Unemployed and educated male labor force (% of population) of Secondary education in 1996 to that in 1999?
Offer a terse response. 0.94. What is the ratio of the Unemployed and educated male labor force (% of population) in Tertiary education in 1996 to that in 1999?
Provide a short and direct response. 0.75. What is the ratio of the Unemployed and educated male labor force (% of population) of Primary education in 1996 to that in 2000?
Give a very brief answer. 1.22. What is the ratio of the Unemployed and educated male labor force (% of population) in Secondary education in 1996 to that in 2000?
Your answer should be compact. 0.95. What is the ratio of the Unemployed and educated male labor force (% of population) in Tertiary education in 1996 to that in 2000?
Offer a terse response. 0.73. What is the ratio of the Unemployed and educated male labor force (% of population) of Primary education in 1996 to that in 2001?
Offer a very short reply. 1.35. What is the ratio of the Unemployed and educated male labor force (% of population) in Secondary education in 1996 to that in 2001?
Offer a very short reply. 0.92. What is the ratio of the Unemployed and educated male labor force (% of population) in Tertiary education in 1996 to that in 2001?
Your answer should be compact. 0.71. What is the ratio of the Unemployed and educated male labor force (% of population) in Primary education in 1996 to that in 2002?
Ensure brevity in your answer.  1.32. What is the ratio of the Unemployed and educated male labor force (% of population) in Secondary education in 1996 to that in 2002?
Keep it short and to the point. 0.98. What is the ratio of the Unemployed and educated male labor force (% of population) in Tertiary education in 1996 to that in 2002?
Your response must be concise. 0.54. What is the ratio of the Unemployed and educated male labor force (% of population) of Primary education in 1996 to that in 2003?
Make the answer very short. 1.48. What is the ratio of the Unemployed and educated male labor force (% of population) of Tertiary education in 1996 to that in 2003?
Your answer should be very brief. 0.51. What is the ratio of the Unemployed and educated male labor force (% of population) in Primary education in 1997 to that in 1998?
Offer a terse response. 1.16. What is the ratio of the Unemployed and educated male labor force (% of population) of Secondary education in 1997 to that in 1998?
Keep it short and to the point. 0.96. What is the ratio of the Unemployed and educated male labor force (% of population) in Tertiary education in 1997 to that in 1998?
Provide a short and direct response. 0.8. What is the ratio of the Unemployed and educated male labor force (% of population) of Primary education in 1997 to that in 1999?
Keep it short and to the point. 1.18. What is the ratio of the Unemployed and educated male labor force (% of population) in Tertiary education in 1997 to that in 1999?
Give a very brief answer. 0.76. What is the ratio of the Unemployed and educated male labor force (% of population) in Primary education in 1997 to that in 2000?
Make the answer very short. 1.18. What is the ratio of the Unemployed and educated male labor force (% of population) in Secondary education in 1997 to that in 2000?
Your answer should be very brief. 0.97. What is the ratio of the Unemployed and educated male labor force (% of population) in Tertiary education in 1997 to that in 2000?
Your answer should be very brief. 0.74. What is the ratio of the Unemployed and educated male labor force (% of population) of Primary education in 1997 to that in 2001?
Provide a short and direct response. 1.31. What is the ratio of the Unemployed and educated male labor force (% of population) in Secondary education in 1997 to that in 2001?
Give a very brief answer. 0.94. What is the ratio of the Unemployed and educated male labor force (% of population) in Tertiary education in 1997 to that in 2001?
Your answer should be very brief. 0.72. What is the ratio of the Unemployed and educated male labor force (% of population) in Primary education in 1997 to that in 2002?
Ensure brevity in your answer.  1.28. What is the ratio of the Unemployed and educated male labor force (% of population) in Secondary education in 1997 to that in 2002?
Provide a succinct answer. 1.01. What is the ratio of the Unemployed and educated male labor force (% of population) of Tertiary education in 1997 to that in 2002?
Offer a very short reply. 0.55. What is the ratio of the Unemployed and educated male labor force (% of population) of Primary education in 1997 to that in 2003?
Ensure brevity in your answer.  1.44. What is the ratio of the Unemployed and educated male labor force (% of population) of Secondary education in 1997 to that in 2003?
Your answer should be very brief. 1. What is the ratio of the Unemployed and educated male labor force (% of population) in Tertiary education in 1997 to that in 2003?
Ensure brevity in your answer.  0.52. What is the ratio of the Unemployed and educated male labor force (% of population) in Primary education in 1998 to that in 1999?
Give a very brief answer. 1.02. What is the ratio of the Unemployed and educated male labor force (% of population) of Secondary education in 1998 to that in 1999?
Keep it short and to the point. 1. What is the ratio of the Unemployed and educated male labor force (% of population) of Tertiary education in 1998 to that in 1999?
Provide a short and direct response. 0.95. What is the ratio of the Unemployed and educated male labor force (% of population) in Secondary education in 1998 to that in 2000?
Your answer should be compact. 1.01. What is the ratio of the Unemployed and educated male labor force (% of population) in Tertiary education in 1998 to that in 2000?
Make the answer very short. 0.92. What is the ratio of the Unemployed and educated male labor force (% of population) of Primary education in 1998 to that in 2001?
Provide a short and direct response. 1.13. What is the ratio of the Unemployed and educated male labor force (% of population) in Secondary education in 1998 to that in 2001?
Ensure brevity in your answer.  0.98. What is the ratio of the Unemployed and educated male labor force (% of population) in Tertiary education in 1998 to that in 2001?
Your response must be concise. 0.9. What is the ratio of the Unemployed and educated male labor force (% of population) of Primary education in 1998 to that in 2002?
Provide a succinct answer. 1.11. What is the ratio of the Unemployed and educated male labor force (% of population) of Secondary education in 1998 to that in 2002?
Provide a succinct answer. 1.05. What is the ratio of the Unemployed and educated male labor force (% of population) of Tertiary education in 1998 to that in 2002?
Ensure brevity in your answer.  0.69. What is the ratio of the Unemployed and educated male labor force (% of population) of Primary education in 1998 to that in 2003?
Provide a short and direct response. 1.24. What is the ratio of the Unemployed and educated male labor force (% of population) of Secondary education in 1998 to that in 2003?
Your response must be concise. 1.04. What is the ratio of the Unemployed and educated male labor force (% of population) of Tertiary education in 1998 to that in 2003?
Your response must be concise. 0.65. What is the ratio of the Unemployed and educated male labor force (% of population) of Primary education in 1999 to that in 2000?
Your answer should be compact. 1.01. What is the ratio of the Unemployed and educated male labor force (% of population) in Secondary education in 1999 to that in 2000?
Ensure brevity in your answer.  1.01. What is the ratio of the Unemployed and educated male labor force (% of population) of Tertiary education in 1999 to that in 2000?
Offer a very short reply. 0.97. What is the ratio of the Unemployed and educated male labor force (% of population) in Primary education in 1999 to that in 2001?
Your answer should be compact. 1.11. What is the ratio of the Unemployed and educated male labor force (% of population) in Secondary education in 1999 to that in 2001?
Offer a terse response. 0.98. What is the ratio of the Unemployed and educated male labor force (% of population) of Tertiary education in 1999 to that in 2001?
Your response must be concise. 0.94. What is the ratio of the Unemployed and educated male labor force (% of population) of Primary education in 1999 to that in 2002?
Your response must be concise. 1.09. What is the ratio of the Unemployed and educated male labor force (% of population) of Secondary education in 1999 to that in 2002?
Provide a short and direct response. 1.05. What is the ratio of the Unemployed and educated male labor force (% of population) of Tertiary education in 1999 to that in 2002?
Make the answer very short. 0.72. What is the ratio of the Unemployed and educated male labor force (% of population) of Primary education in 1999 to that in 2003?
Ensure brevity in your answer.  1.22. What is the ratio of the Unemployed and educated male labor force (% of population) of Secondary education in 1999 to that in 2003?
Keep it short and to the point. 1.04. What is the ratio of the Unemployed and educated male labor force (% of population) of Tertiary education in 1999 to that in 2003?
Ensure brevity in your answer.  0.68. What is the ratio of the Unemployed and educated male labor force (% of population) in Primary education in 2000 to that in 2001?
Your response must be concise. 1.11. What is the ratio of the Unemployed and educated male labor force (% of population) in Secondary education in 2000 to that in 2001?
Ensure brevity in your answer.  0.97. What is the ratio of the Unemployed and educated male labor force (% of population) in Tertiary education in 2000 to that in 2001?
Keep it short and to the point. 0.97. What is the ratio of the Unemployed and educated male labor force (% of population) of Primary education in 2000 to that in 2002?
Offer a terse response. 1.08. What is the ratio of the Unemployed and educated male labor force (% of population) of Secondary education in 2000 to that in 2002?
Offer a terse response. 1.04. What is the ratio of the Unemployed and educated male labor force (% of population) of Tertiary education in 2000 to that in 2002?
Ensure brevity in your answer.  0.74. What is the ratio of the Unemployed and educated male labor force (% of population) of Primary education in 2000 to that in 2003?
Your response must be concise. 1.22. What is the ratio of the Unemployed and educated male labor force (% of population) in Secondary education in 2000 to that in 2003?
Offer a very short reply. 1.03. What is the ratio of the Unemployed and educated male labor force (% of population) in Tertiary education in 2000 to that in 2003?
Your response must be concise. 0.7. What is the ratio of the Unemployed and educated male labor force (% of population) of Primary education in 2001 to that in 2002?
Your response must be concise. 0.98. What is the ratio of the Unemployed and educated male labor force (% of population) in Secondary education in 2001 to that in 2002?
Your response must be concise. 1.07. What is the ratio of the Unemployed and educated male labor force (% of population) of Tertiary education in 2001 to that in 2002?
Your answer should be compact. 0.76. What is the ratio of the Unemployed and educated male labor force (% of population) of Primary education in 2001 to that in 2003?
Offer a terse response. 1.1. What is the ratio of the Unemployed and educated male labor force (% of population) of Secondary education in 2001 to that in 2003?
Give a very brief answer. 1.06. What is the ratio of the Unemployed and educated male labor force (% of population) of Tertiary education in 2001 to that in 2003?
Your answer should be compact. 0.72. What is the ratio of the Unemployed and educated male labor force (% of population) in Primary education in 2002 to that in 2003?
Your answer should be compact. 1.13. What is the ratio of the Unemployed and educated male labor force (% of population) of Secondary education in 2002 to that in 2003?
Keep it short and to the point. 0.99. What is the ratio of the Unemployed and educated male labor force (% of population) of Tertiary education in 2002 to that in 2003?
Your response must be concise. 0.95. What is the difference between the highest and the second highest Unemployed and educated male labor force (% of population) in Secondary education?
Provide a short and direct response. 1.1. What is the difference between the highest and the second highest Unemployed and educated male labor force (% of population) of Tertiary education?
Offer a terse response. 0.8. What is the difference between the highest and the lowest Unemployed and educated male labor force (% of population) in Tertiary education?
Make the answer very short. 8.6. 